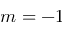Convert formula to latex. <formula><loc_0><loc_0><loc_500><loc_500>m = - 1</formula> 